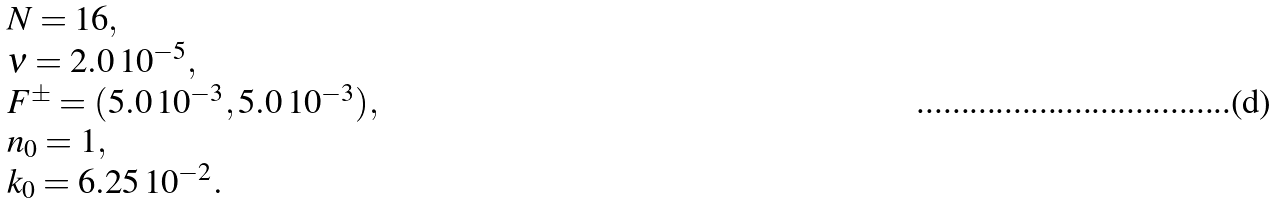Convert formula to latex. <formula><loc_0><loc_0><loc_500><loc_500>\begin{array} { l l l l l } & N = 1 6 , \\ & \nu = 2 . 0 \, 1 0 ^ { - 5 } , \\ & F ^ { \pm } = ( 5 . 0 \, 1 0 ^ { - 3 } , 5 . 0 \, 1 0 ^ { - 3 } ) , \\ & n _ { 0 } = 1 , \\ & k _ { 0 } = 6 . 2 5 \, 1 0 ^ { - 2 } . \end{array}</formula> 